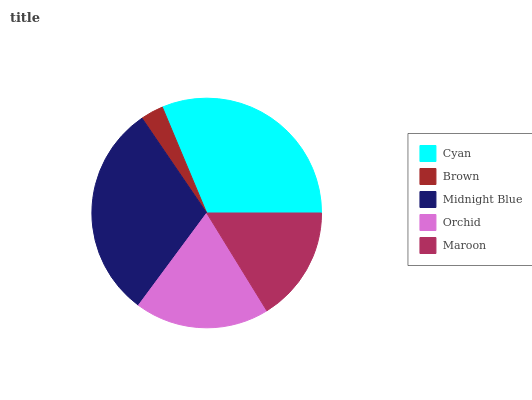Is Brown the minimum?
Answer yes or no. Yes. Is Cyan the maximum?
Answer yes or no. Yes. Is Midnight Blue the minimum?
Answer yes or no. No. Is Midnight Blue the maximum?
Answer yes or no. No. Is Midnight Blue greater than Brown?
Answer yes or no. Yes. Is Brown less than Midnight Blue?
Answer yes or no. Yes. Is Brown greater than Midnight Blue?
Answer yes or no. No. Is Midnight Blue less than Brown?
Answer yes or no. No. Is Orchid the high median?
Answer yes or no. Yes. Is Orchid the low median?
Answer yes or no. Yes. Is Midnight Blue the high median?
Answer yes or no. No. Is Midnight Blue the low median?
Answer yes or no. No. 